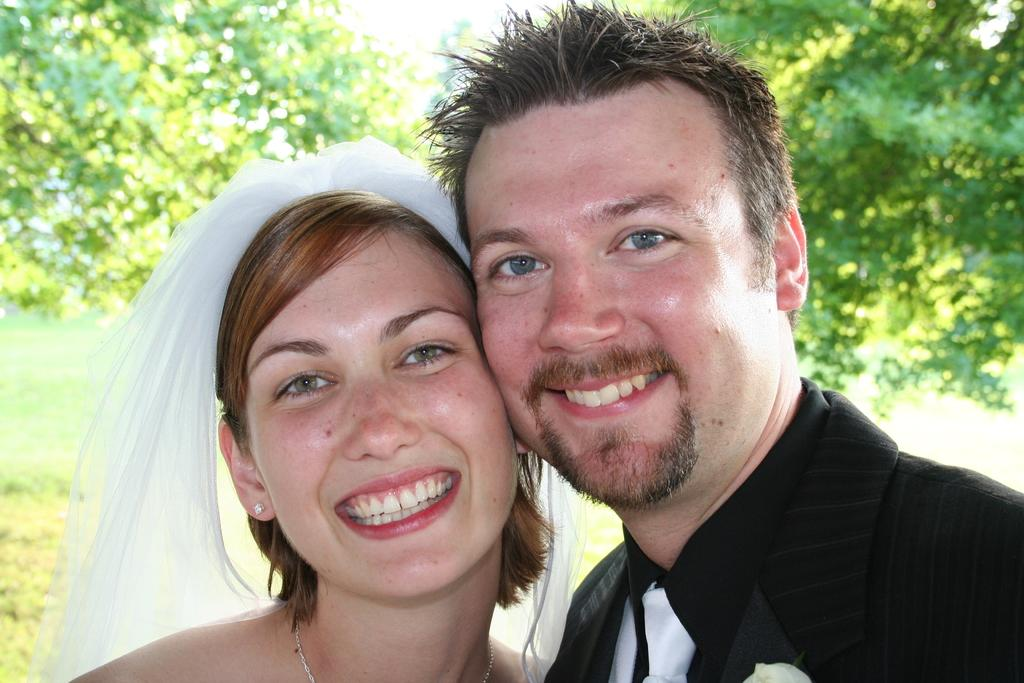How many people are in the image? There are two people in the image. What is the facial expression of the people in the image? The people are smiling. What can be seen in the background of the image? There are trees visible in the background of the image. What is visible in the sky in the image? The sky is visible in the image. What type of paper is being used by the mice in the image? There are no mice present in the image, so it is not possible to determine what type of paper they might be using. 